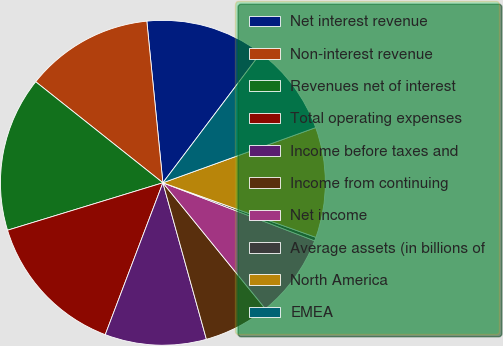Convert chart. <chart><loc_0><loc_0><loc_500><loc_500><pie_chart><fcel>Net interest revenue<fcel>Non-interest revenue<fcel>Revenues net of interest<fcel>Total operating expenses<fcel>Income before taxes and<fcel>Income from continuing<fcel>Net income<fcel>Average assets (in billions of<fcel>North America<fcel>EMEA<nl><fcel>11.86%<fcel>12.74%<fcel>15.4%<fcel>14.51%<fcel>10.09%<fcel>6.55%<fcel>8.32%<fcel>0.36%<fcel>10.97%<fcel>9.2%<nl></chart> 